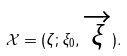<formula> <loc_0><loc_0><loc_500><loc_500>\mathcal { X } = ( \zeta ; \xi _ { 0 } , \overrightarrow { \xi } ) .</formula> 